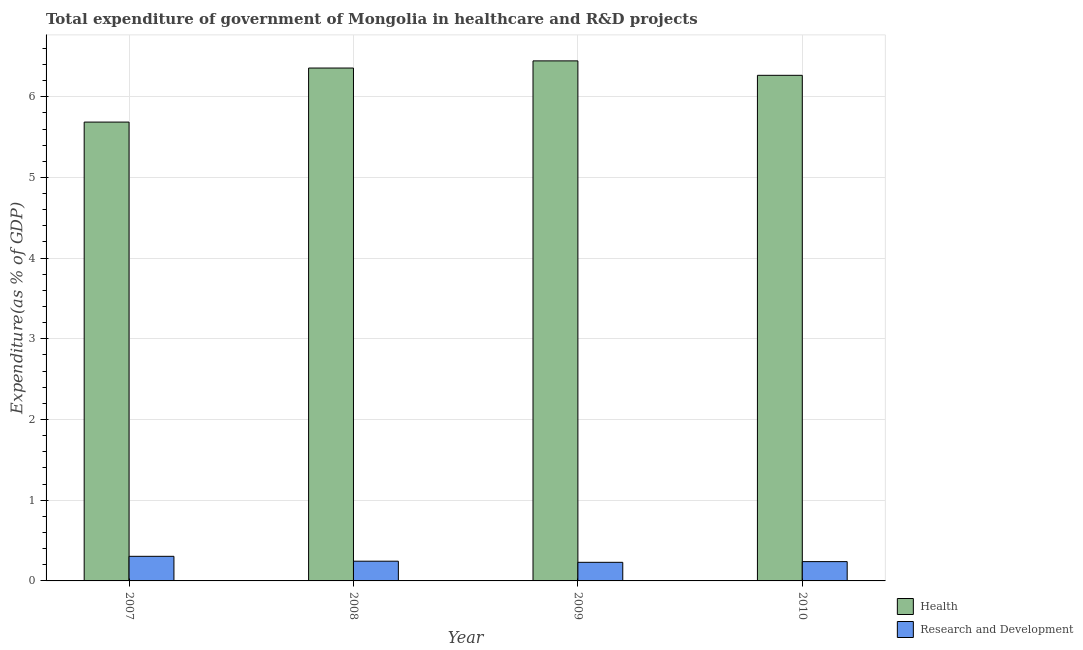How many different coloured bars are there?
Your response must be concise. 2. Are the number of bars per tick equal to the number of legend labels?
Keep it short and to the point. Yes. How many bars are there on the 2nd tick from the left?
Keep it short and to the point. 2. What is the label of the 1st group of bars from the left?
Ensure brevity in your answer.  2007. In how many cases, is the number of bars for a given year not equal to the number of legend labels?
Your answer should be compact. 0. What is the expenditure in r&d in 2009?
Provide a succinct answer. 0.23. Across all years, what is the maximum expenditure in healthcare?
Offer a terse response. 6.44. Across all years, what is the minimum expenditure in r&d?
Offer a very short reply. 0.23. In which year was the expenditure in healthcare minimum?
Offer a terse response. 2007. What is the total expenditure in healthcare in the graph?
Provide a succinct answer. 24.75. What is the difference between the expenditure in r&d in 2007 and that in 2010?
Keep it short and to the point. 0.07. What is the difference between the expenditure in healthcare in 2008 and the expenditure in r&d in 2007?
Offer a very short reply. 0.67. What is the average expenditure in healthcare per year?
Make the answer very short. 6.19. In the year 2009, what is the difference between the expenditure in healthcare and expenditure in r&d?
Your response must be concise. 0. In how many years, is the expenditure in r&d greater than 3.8 %?
Provide a short and direct response. 0. What is the ratio of the expenditure in r&d in 2008 to that in 2010?
Keep it short and to the point. 1.02. Is the expenditure in r&d in 2008 less than that in 2010?
Your answer should be compact. No. What is the difference between the highest and the second highest expenditure in r&d?
Your answer should be compact. 0.06. What is the difference between the highest and the lowest expenditure in r&d?
Your response must be concise. 0.07. Is the sum of the expenditure in r&d in 2007 and 2008 greater than the maximum expenditure in healthcare across all years?
Give a very brief answer. Yes. What does the 2nd bar from the left in 2007 represents?
Give a very brief answer. Research and Development. What does the 2nd bar from the right in 2008 represents?
Give a very brief answer. Health. How many years are there in the graph?
Provide a succinct answer. 4. What is the difference between two consecutive major ticks on the Y-axis?
Make the answer very short. 1. Are the values on the major ticks of Y-axis written in scientific E-notation?
Provide a short and direct response. No. Does the graph contain any zero values?
Your answer should be very brief. No. Does the graph contain grids?
Your answer should be very brief. Yes. Where does the legend appear in the graph?
Offer a terse response. Bottom right. What is the title of the graph?
Provide a short and direct response. Total expenditure of government of Mongolia in healthcare and R&D projects. Does "Merchandise exports" appear as one of the legend labels in the graph?
Your response must be concise. No. What is the label or title of the Y-axis?
Provide a succinct answer. Expenditure(as % of GDP). What is the Expenditure(as % of GDP) of Health in 2007?
Keep it short and to the point. 5.69. What is the Expenditure(as % of GDP) in Research and Development in 2007?
Offer a very short reply. 0.3. What is the Expenditure(as % of GDP) in Health in 2008?
Make the answer very short. 6.36. What is the Expenditure(as % of GDP) of Research and Development in 2008?
Provide a short and direct response. 0.24. What is the Expenditure(as % of GDP) in Health in 2009?
Ensure brevity in your answer.  6.44. What is the Expenditure(as % of GDP) in Research and Development in 2009?
Give a very brief answer. 0.23. What is the Expenditure(as % of GDP) of Health in 2010?
Your answer should be compact. 6.27. What is the Expenditure(as % of GDP) in Research and Development in 2010?
Offer a terse response. 0.24. Across all years, what is the maximum Expenditure(as % of GDP) in Health?
Your answer should be very brief. 6.44. Across all years, what is the maximum Expenditure(as % of GDP) of Research and Development?
Your answer should be compact. 0.3. Across all years, what is the minimum Expenditure(as % of GDP) of Health?
Offer a very short reply. 5.69. Across all years, what is the minimum Expenditure(as % of GDP) in Research and Development?
Your answer should be very brief. 0.23. What is the total Expenditure(as % of GDP) of Health in the graph?
Give a very brief answer. 24.75. What is the total Expenditure(as % of GDP) in Research and Development in the graph?
Provide a short and direct response. 1.02. What is the difference between the Expenditure(as % of GDP) in Health in 2007 and that in 2008?
Keep it short and to the point. -0.67. What is the difference between the Expenditure(as % of GDP) of Research and Development in 2007 and that in 2008?
Your response must be concise. 0.06. What is the difference between the Expenditure(as % of GDP) of Health in 2007 and that in 2009?
Your answer should be very brief. -0.76. What is the difference between the Expenditure(as % of GDP) in Research and Development in 2007 and that in 2009?
Offer a very short reply. 0.07. What is the difference between the Expenditure(as % of GDP) in Health in 2007 and that in 2010?
Offer a terse response. -0.58. What is the difference between the Expenditure(as % of GDP) of Research and Development in 2007 and that in 2010?
Give a very brief answer. 0.07. What is the difference between the Expenditure(as % of GDP) in Health in 2008 and that in 2009?
Provide a short and direct response. -0.09. What is the difference between the Expenditure(as % of GDP) of Research and Development in 2008 and that in 2009?
Your response must be concise. 0.01. What is the difference between the Expenditure(as % of GDP) in Health in 2008 and that in 2010?
Your answer should be very brief. 0.09. What is the difference between the Expenditure(as % of GDP) of Research and Development in 2008 and that in 2010?
Offer a very short reply. 0.01. What is the difference between the Expenditure(as % of GDP) in Health in 2009 and that in 2010?
Offer a terse response. 0.18. What is the difference between the Expenditure(as % of GDP) of Research and Development in 2009 and that in 2010?
Your answer should be compact. -0.01. What is the difference between the Expenditure(as % of GDP) in Health in 2007 and the Expenditure(as % of GDP) in Research and Development in 2008?
Your answer should be very brief. 5.44. What is the difference between the Expenditure(as % of GDP) of Health in 2007 and the Expenditure(as % of GDP) of Research and Development in 2009?
Provide a succinct answer. 5.46. What is the difference between the Expenditure(as % of GDP) of Health in 2007 and the Expenditure(as % of GDP) of Research and Development in 2010?
Provide a short and direct response. 5.45. What is the difference between the Expenditure(as % of GDP) of Health in 2008 and the Expenditure(as % of GDP) of Research and Development in 2009?
Provide a succinct answer. 6.13. What is the difference between the Expenditure(as % of GDP) in Health in 2008 and the Expenditure(as % of GDP) in Research and Development in 2010?
Ensure brevity in your answer.  6.12. What is the difference between the Expenditure(as % of GDP) in Health in 2009 and the Expenditure(as % of GDP) in Research and Development in 2010?
Give a very brief answer. 6.21. What is the average Expenditure(as % of GDP) in Health per year?
Provide a short and direct response. 6.19. What is the average Expenditure(as % of GDP) in Research and Development per year?
Provide a short and direct response. 0.25. In the year 2007, what is the difference between the Expenditure(as % of GDP) of Health and Expenditure(as % of GDP) of Research and Development?
Offer a very short reply. 5.38. In the year 2008, what is the difference between the Expenditure(as % of GDP) in Health and Expenditure(as % of GDP) in Research and Development?
Your answer should be compact. 6.11. In the year 2009, what is the difference between the Expenditure(as % of GDP) in Health and Expenditure(as % of GDP) in Research and Development?
Your answer should be very brief. 6.21. In the year 2010, what is the difference between the Expenditure(as % of GDP) in Health and Expenditure(as % of GDP) in Research and Development?
Offer a terse response. 6.03. What is the ratio of the Expenditure(as % of GDP) of Health in 2007 to that in 2008?
Give a very brief answer. 0.89. What is the ratio of the Expenditure(as % of GDP) of Research and Development in 2007 to that in 2008?
Keep it short and to the point. 1.25. What is the ratio of the Expenditure(as % of GDP) of Health in 2007 to that in 2009?
Make the answer very short. 0.88. What is the ratio of the Expenditure(as % of GDP) in Research and Development in 2007 to that in 2009?
Make the answer very short. 1.32. What is the ratio of the Expenditure(as % of GDP) of Health in 2007 to that in 2010?
Ensure brevity in your answer.  0.91. What is the ratio of the Expenditure(as % of GDP) of Research and Development in 2007 to that in 2010?
Provide a succinct answer. 1.27. What is the ratio of the Expenditure(as % of GDP) in Health in 2008 to that in 2009?
Make the answer very short. 0.99. What is the ratio of the Expenditure(as % of GDP) of Research and Development in 2008 to that in 2009?
Provide a succinct answer. 1.06. What is the ratio of the Expenditure(as % of GDP) of Health in 2008 to that in 2010?
Provide a short and direct response. 1.01. What is the ratio of the Expenditure(as % of GDP) of Research and Development in 2008 to that in 2010?
Provide a short and direct response. 1.02. What is the ratio of the Expenditure(as % of GDP) in Health in 2009 to that in 2010?
Offer a terse response. 1.03. What is the ratio of the Expenditure(as % of GDP) of Research and Development in 2009 to that in 2010?
Provide a short and direct response. 0.96. What is the difference between the highest and the second highest Expenditure(as % of GDP) of Health?
Your answer should be very brief. 0.09. What is the difference between the highest and the second highest Expenditure(as % of GDP) in Research and Development?
Your answer should be very brief. 0.06. What is the difference between the highest and the lowest Expenditure(as % of GDP) of Health?
Offer a very short reply. 0.76. What is the difference between the highest and the lowest Expenditure(as % of GDP) of Research and Development?
Offer a terse response. 0.07. 